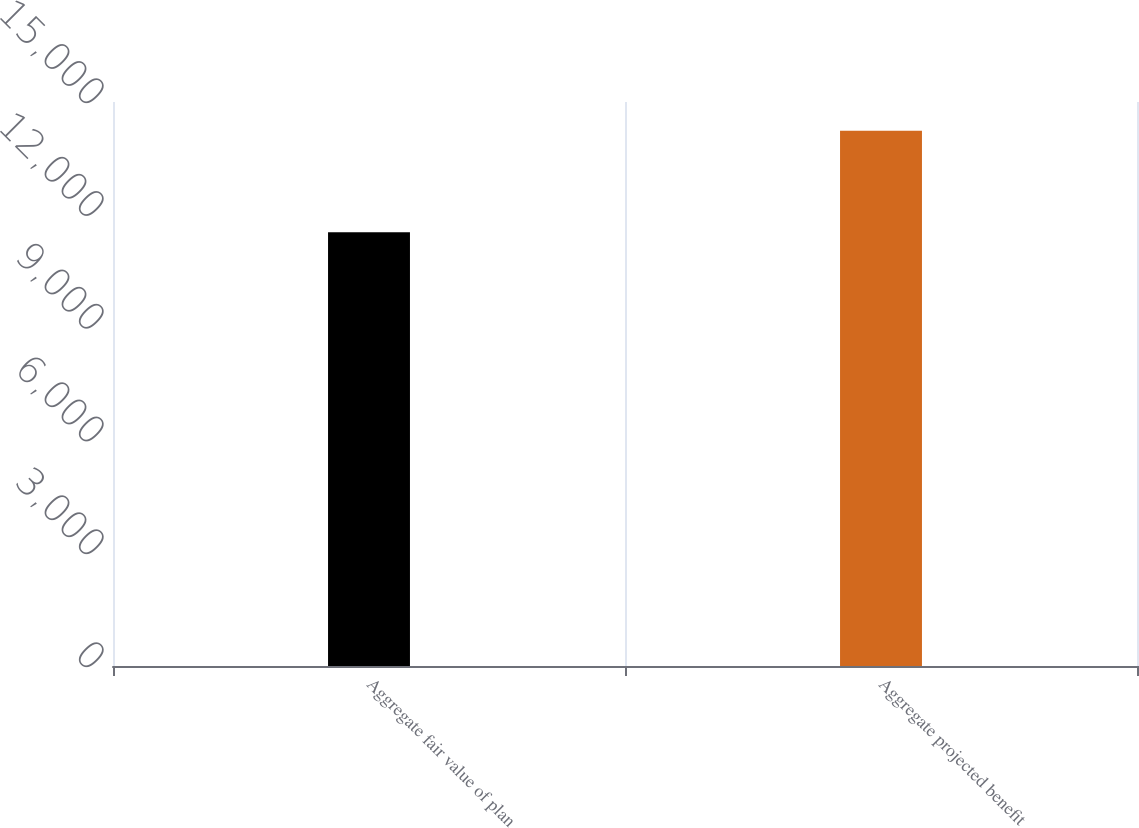Convert chart to OTSL. <chart><loc_0><loc_0><loc_500><loc_500><bar_chart><fcel>Aggregate fair value of plan<fcel>Aggregate projected benefit<nl><fcel>11536<fcel>14237<nl></chart> 